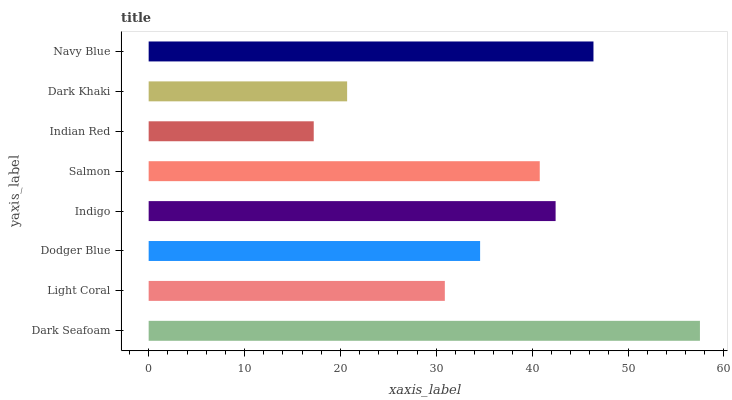Is Indian Red the minimum?
Answer yes or no. Yes. Is Dark Seafoam the maximum?
Answer yes or no. Yes. Is Light Coral the minimum?
Answer yes or no. No. Is Light Coral the maximum?
Answer yes or no. No. Is Dark Seafoam greater than Light Coral?
Answer yes or no. Yes. Is Light Coral less than Dark Seafoam?
Answer yes or no. Yes. Is Light Coral greater than Dark Seafoam?
Answer yes or no. No. Is Dark Seafoam less than Light Coral?
Answer yes or no. No. Is Salmon the high median?
Answer yes or no. Yes. Is Dodger Blue the low median?
Answer yes or no. Yes. Is Navy Blue the high median?
Answer yes or no. No. Is Dark Khaki the low median?
Answer yes or no. No. 